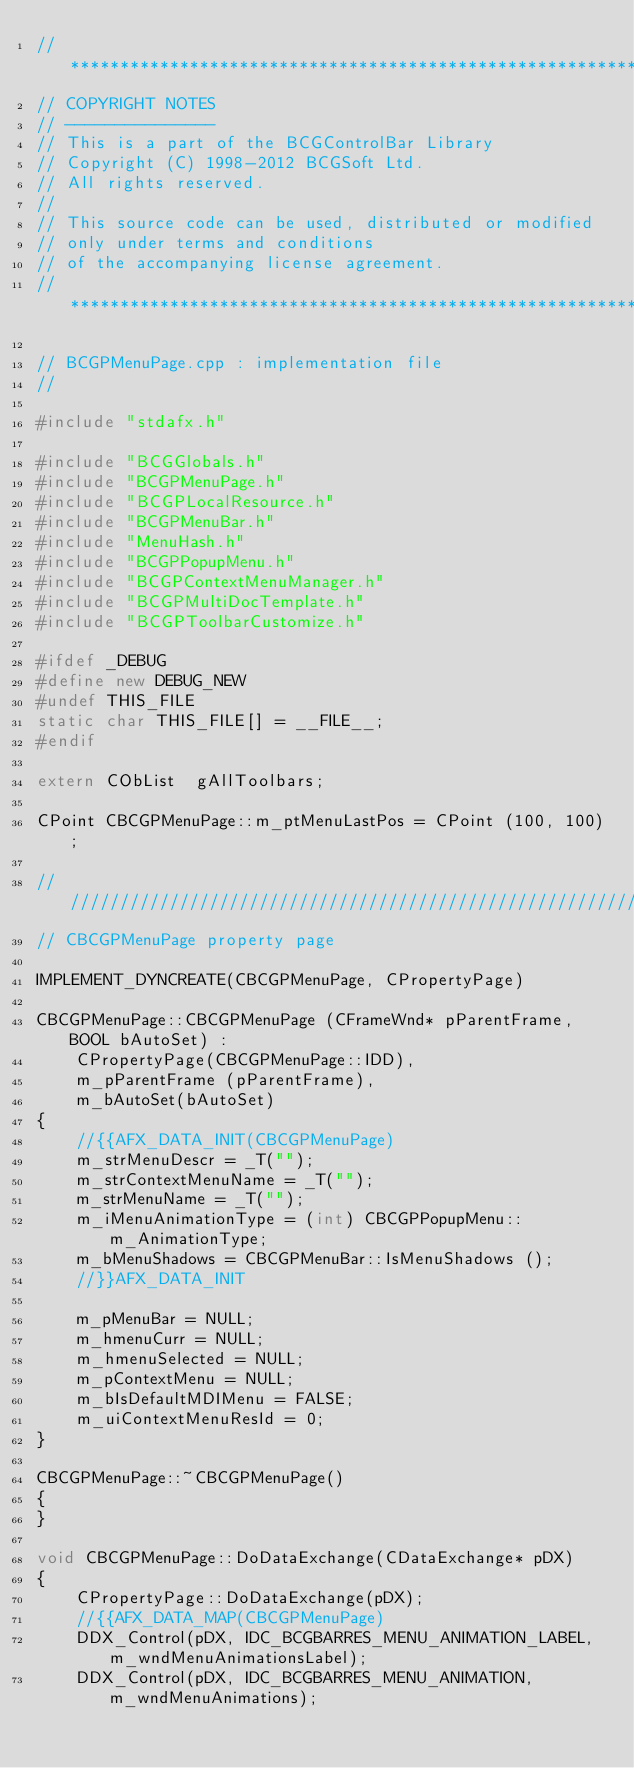<code> <loc_0><loc_0><loc_500><loc_500><_C++_>//*******************************************************************************
// COPYRIGHT NOTES
// ---------------
// This is a part of the BCGControlBar Library
// Copyright (C) 1998-2012 BCGSoft Ltd.
// All rights reserved.
//
// This source code can be used, distributed or modified
// only under terms and conditions 
// of the accompanying license agreement.
//*******************************************************************************

// BCGPMenuPage.cpp : implementation file
//

#include "stdafx.h"

#include "BCGGlobals.h"
#include "BCGPMenuPage.h"
#include "BCGPLocalResource.h"
#include "BCGPMenuBar.h"
#include "MenuHash.h"
#include "BCGPPopupMenu.h"
#include "BCGPContextMenuManager.h"
#include "BCGPMultiDocTemplate.h"
#include "BCGPToolbarCustomize.h"

#ifdef _DEBUG
#define new DEBUG_NEW
#undef THIS_FILE
static char THIS_FILE[] = __FILE__;
#endif

extern CObList	gAllToolbars;

CPoint CBCGPMenuPage::m_ptMenuLastPos = CPoint (100, 100);

/////////////////////////////////////////////////////////////////////////////
// CBCGPMenuPage property page

IMPLEMENT_DYNCREATE(CBCGPMenuPage, CPropertyPage)

CBCGPMenuPage::CBCGPMenuPage (CFrameWnd* pParentFrame, BOOL bAutoSet) :
	CPropertyPage(CBCGPMenuPage::IDD),
	m_pParentFrame (pParentFrame),
	m_bAutoSet(bAutoSet)
{
	//{{AFX_DATA_INIT(CBCGPMenuPage)
	m_strMenuDescr = _T("");
	m_strContextMenuName = _T("");
	m_strMenuName = _T("");
	m_iMenuAnimationType = (int) CBCGPPopupMenu::m_AnimationType;
	m_bMenuShadows = CBCGPMenuBar::IsMenuShadows ();
	//}}AFX_DATA_INIT

	m_pMenuBar = NULL;
	m_hmenuCurr = NULL;
	m_hmenuSelected = NULL;
	m_pContextMenu = NULL;
	m_bIsDefaultMDIMenu = FALSE;
	m_uiContextMenuResId = 0;
}

CBCGPMenuPage::~CBCGPMenuPage()
{
}

void CBCGPMenuPage::DoDataExchange(CDataExchange* pDX)
{
	CPropertyPage::DoDataExchange(pDX);
	//{{AFX_DATA_MAP(CBCGPMenuPage)
	DDX_Control(pDX, IDC_BCGBARRES_MENU_ANIMATION_LABEL, m_wndMenuAnimationsLabel);
	DDX_Control(pDX, IDC_BCGBARRES_MENU_ANIMATION, m_wndMenuAnimations);</code> 